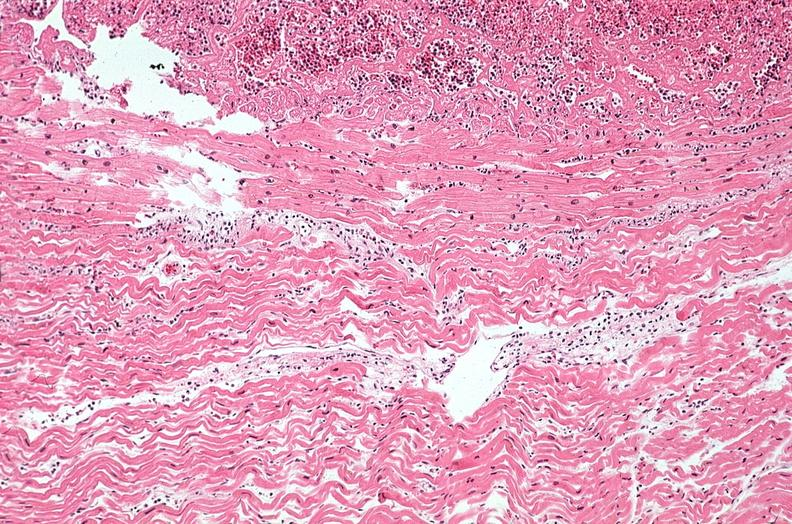s all the fat necrosis present?
Answer the question using a single word or phrase. No 